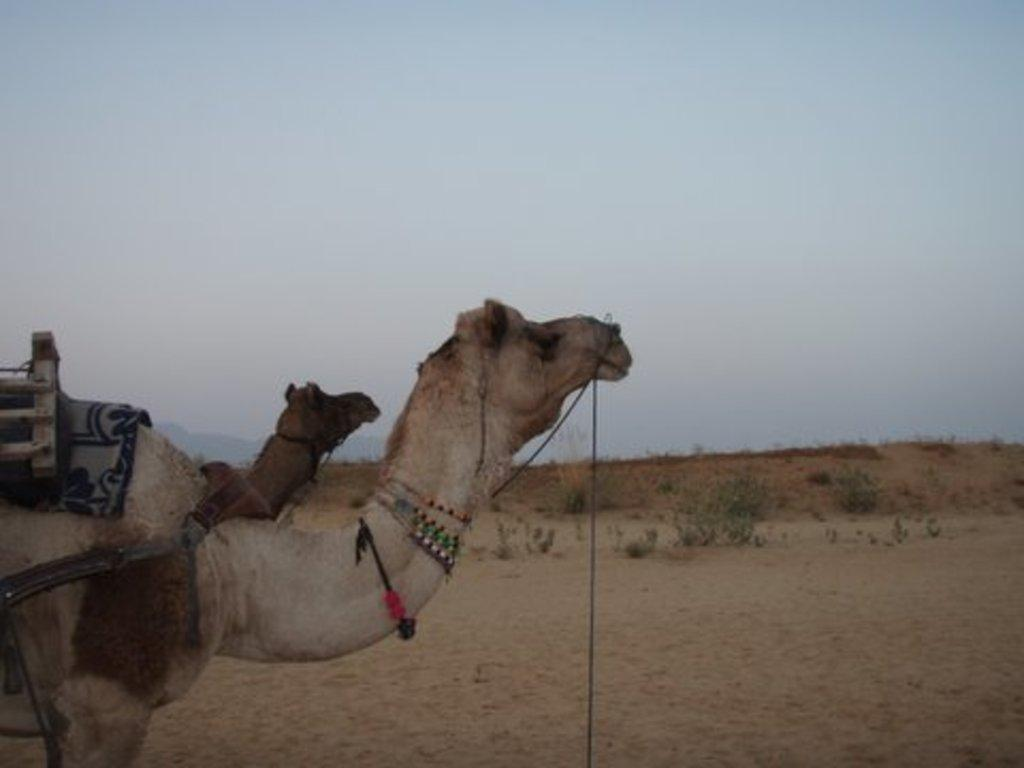What type of living organisms can be seen in the image? There are animals in the image. What colors are the animals in the image? The animals are in cream and brown color. What can be seen in the background of the image? There are plants and the sky visible in the background of the image. What color are the plants in the image? The plants are green in color. What color is the sky in the image? The sky is blue in color. What type of account can be seen in the image? There is no account present in the image; it features animals, plants, and the sky. What time of day is depicted in the image, given the color of the sky? The color of the sky is blue, which can be observed during both day and night, so it cannot be definitively determined from the image alone. 